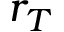<formula> <loc_0><loc_0><loc_500><loc_500>r _ { T }</formula> 